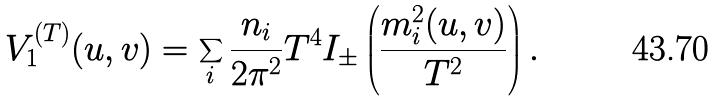<formula> <loc_0><loc_0><loc_500><loc_500>V _ { 1 } ^ { ( T ) } ( u , v ) = \sum _ { i } \frac { n _ { i } } { 2 \pi ^ { 2 } } T ^ { 4 } I _ { \pm } \left ( \frac { m _ { i } ^ { 2 } ( u , v ) } { T ^ { 2 } } \right ) .</formula> 